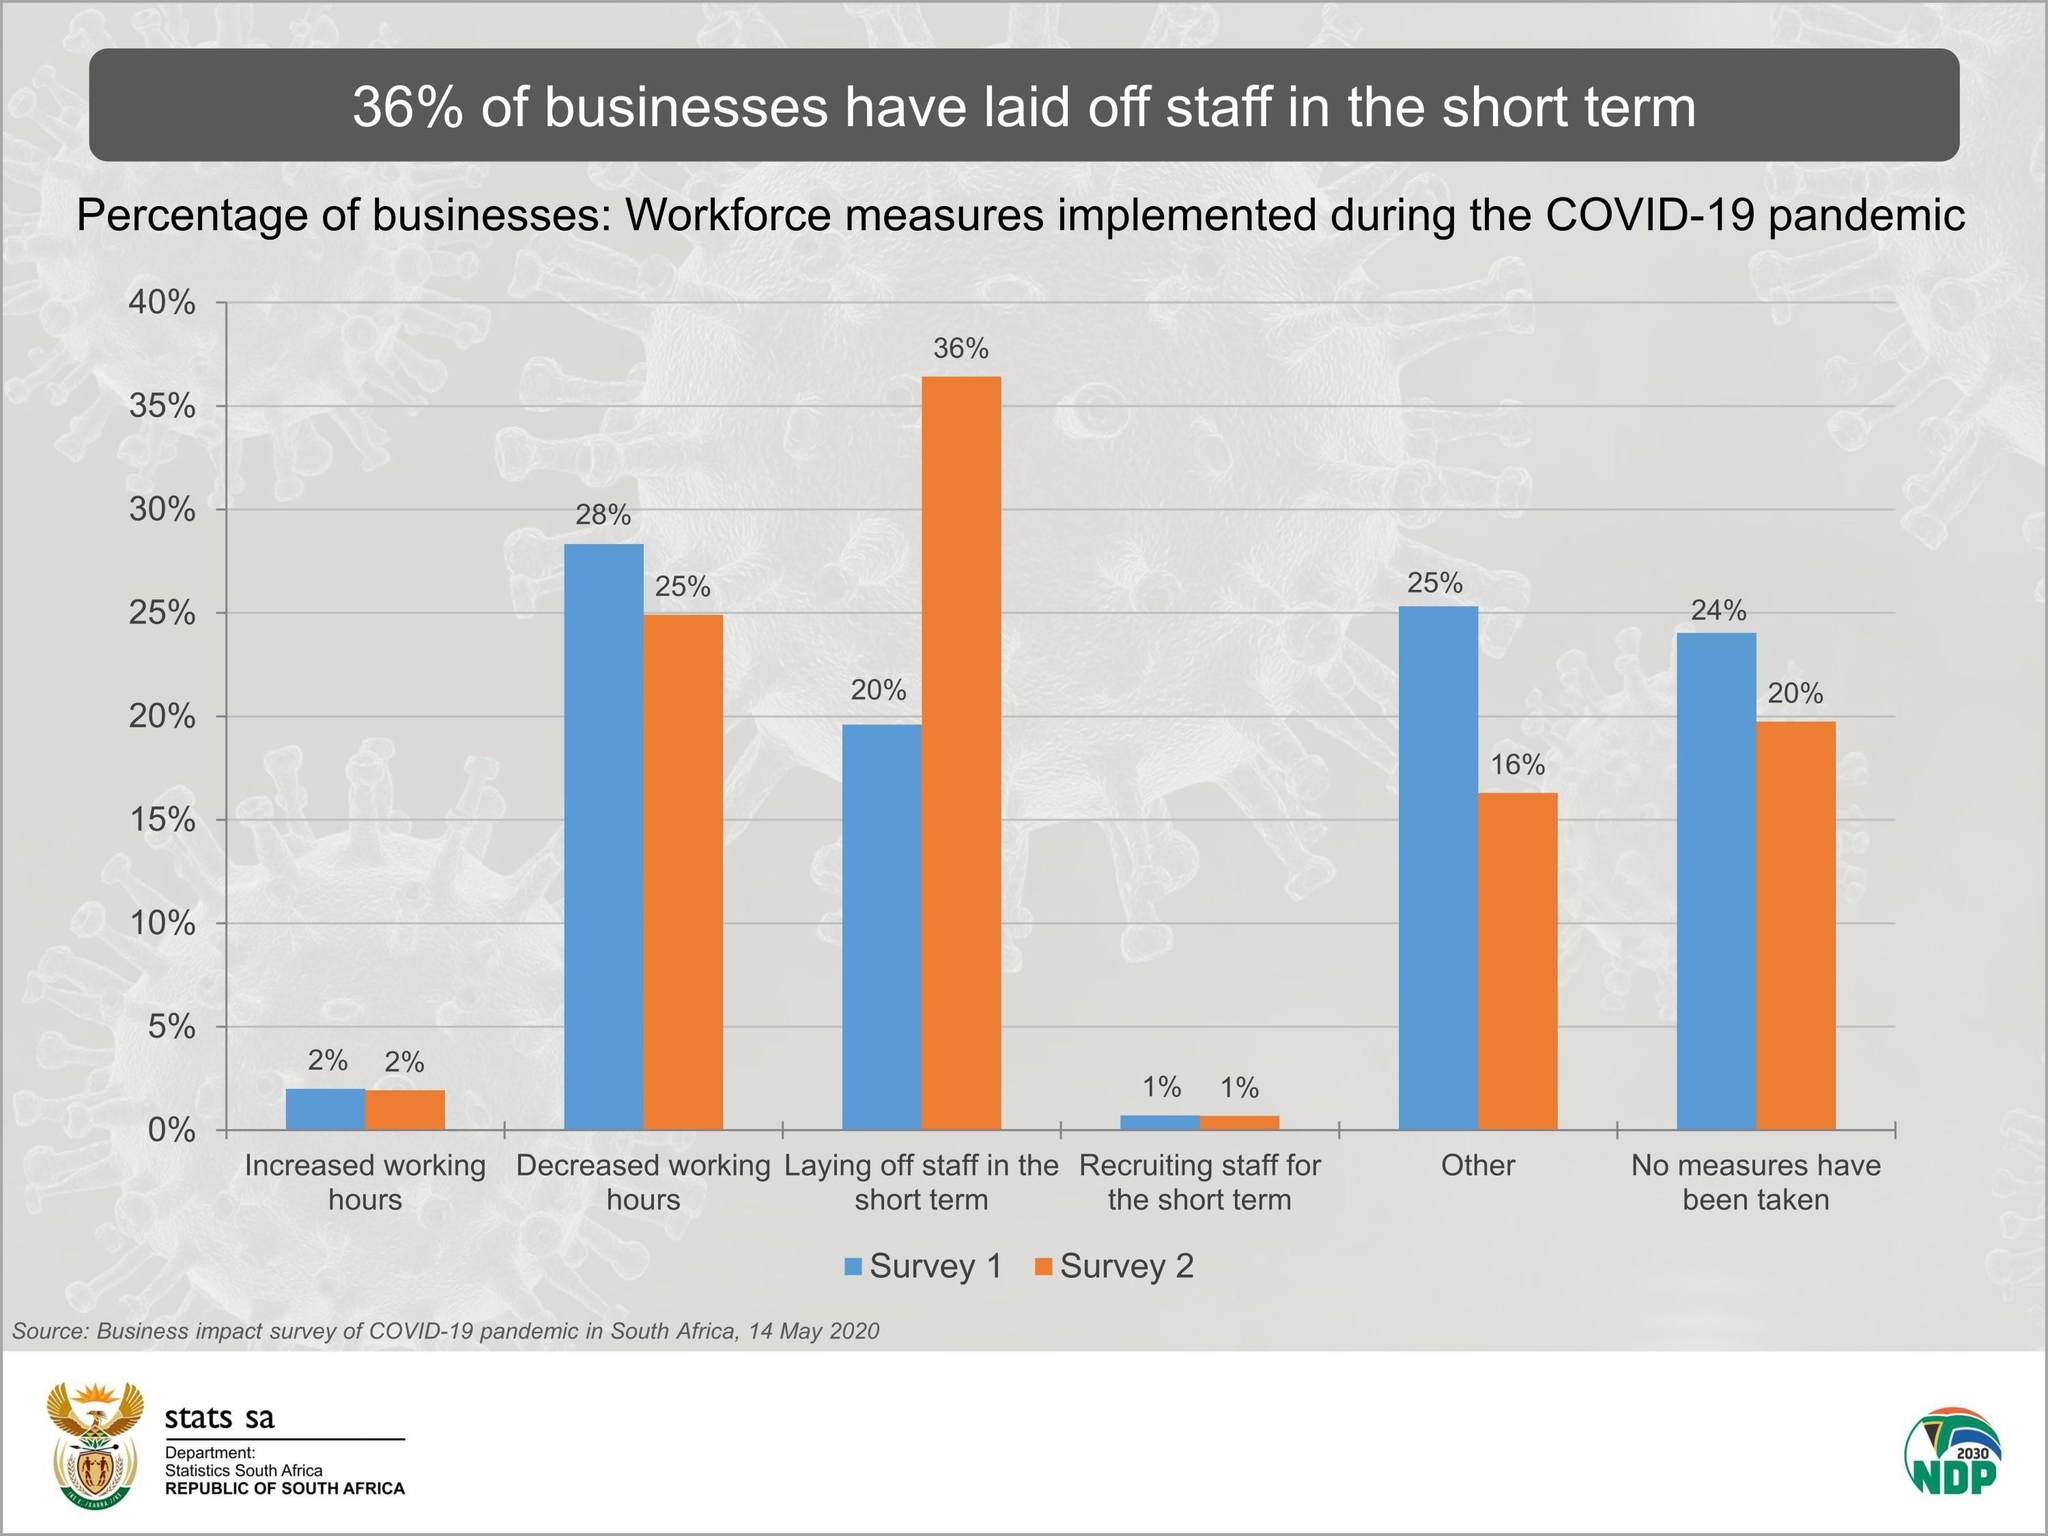List a handful of essential elements in this visual. In both survey one and survey two taken together, only 2% of the recruiting staff participated in the short-term recruitment. The percentage of "other" in Survey One and Survey Two is 41%. In the first survey, there was a 30% decrease in working hours and a 30% increase in working hours. The total increase in working hours between survey one and survey two is 4%. 